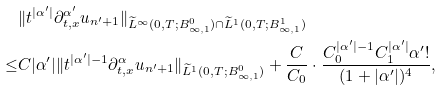<formula> <loc_0><loc_0><loc_500><loc_500>& \| t ^ { | \alpha ^ { \prime } | } \partial _ { t , x } ^ { \alpha ^ { \prime } } u _ { n ^ { \prime } + 1 } \| _ { \widetilde { L } ^ { \infty } ( 0 , T ; B ^ { 0 } _ { \infty , 1 } ) \cap \widetilde { L } ^ { 1 } ( 0 , T ; B ^ { 1 } _ { \infty , 1 } ) } \\ \leq & C | \alpha ^ { \prime } | \| t ^ { | \alpha ^ { \prime } | - 1 } \partial _ { t , x } ^ { \alpha } u _ { n ^ { \prime } + 1 } \| _ { \widetilde { L } ^ { 1 } ( 0 , T ; B ^ { 0 } _ { \infty , 1 } ) } + \frac { C } { C _ { 0 } } \cdot \frac { C _ { 0 } ^ { | \alpha ^ { \prime } | - 1 } C _ { 1 } ^ { | \alpha ^ { \prime } | } \alpha ^ { \prime } ! } { ( 1 + | \alpha ^ { \prime } | ) ^ { 4 } } ,</formula> 